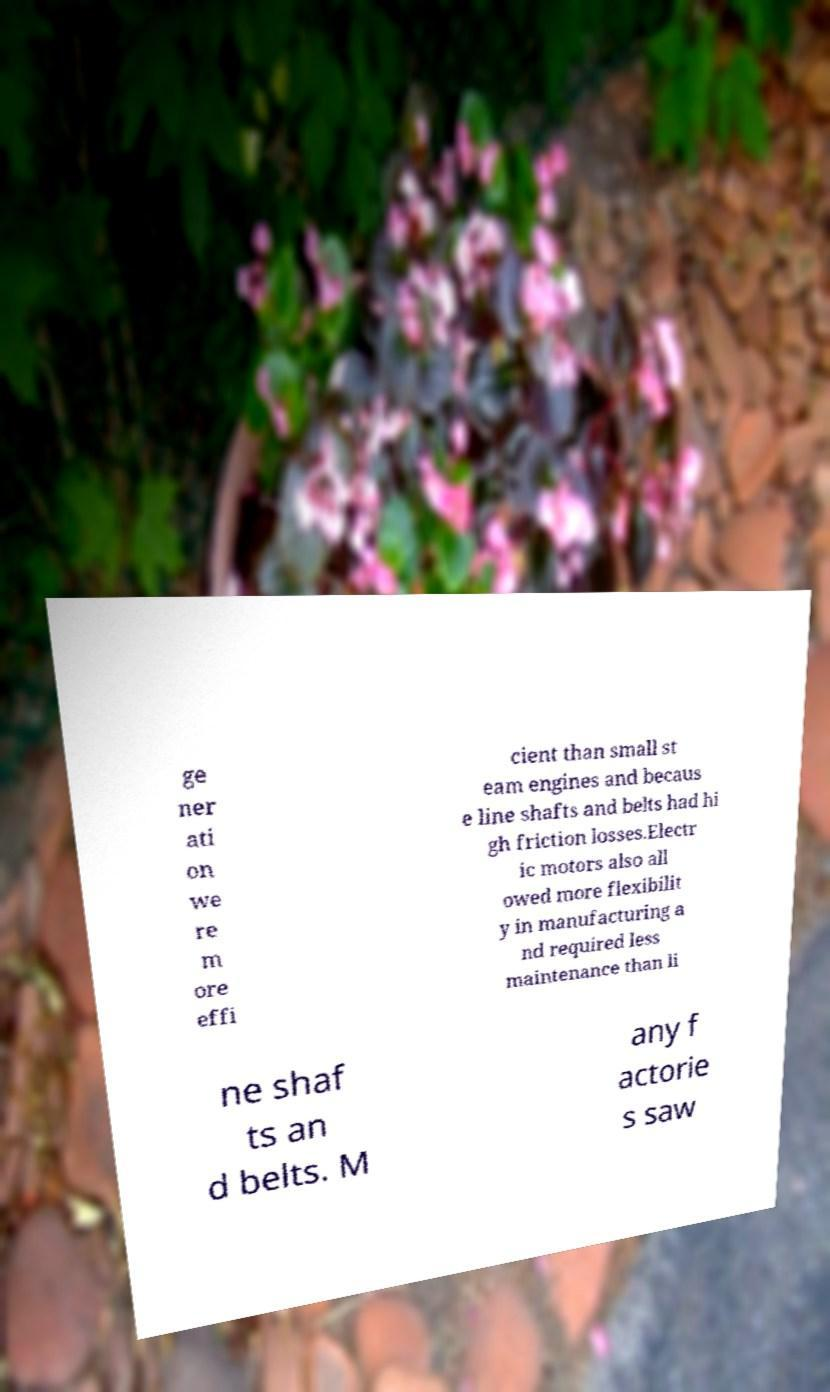Please identify and transcribe the text found in this image. ge ner ati on we re m ore effi cient than small st eam engines and becaus e line shafts and belts had hi gh friction losses.Electr ic motors also all owed more flexibilit y in manufacturing a nd required less maintenance than li ne shaf ts an d belts. M any f actorie s saw 